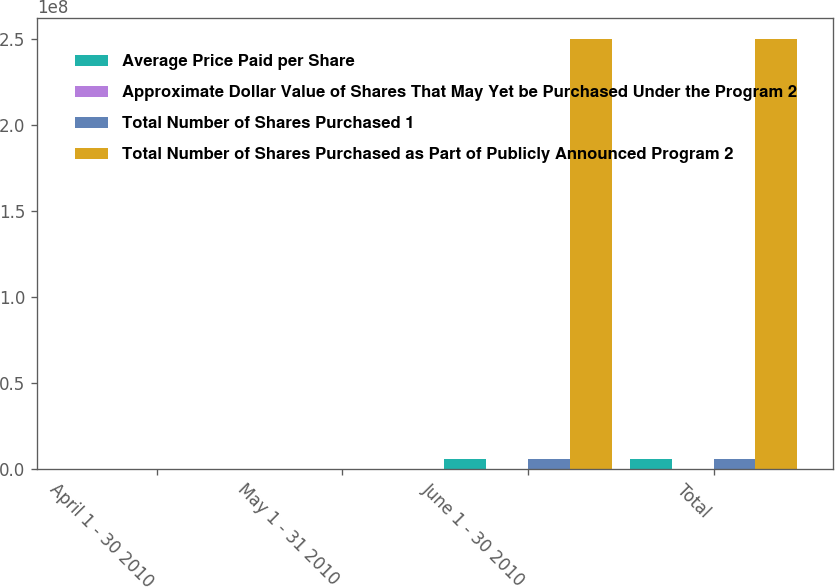Convert chart to OTSL. <chart><loc_0><loc_0><loc_500><loc_500><stacked_bar_chart><ecel><fcel>April 1 - 30 2010<fcel>May 1 - 31 2010<fcel>June 1 - 30 2010<fcel>Total<nl><fcel>Average Price Paid per Share<fcel>817<fcel>6179<fcel>5.7586e+06<fcel>5.7656e+06<nl><fcel>Approximate Dollar Value of Shares That May Yet be Purchased Under the Program 2<fcel>35.68<fcel>34.92<fcel>34.72<fcel>34.72<nl><fcel>Total Number of Shares Purchased 1<fcel>0<fcel>0<fcel>5.7582e+06<fcel>5.7582e+06<nl><fcel>Total Number of Shares Purchased as Part of Publicly Announced Program 2<fcel>3498<fcel>3498<fcel>2.50089e+08<fcel>2.50089e+08<nl></chart> 